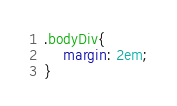<code> <loc_0><loc_0><loc_500><loc_500><_CSS_>.bodyDiv{
    margin: 2em;
}</code> 